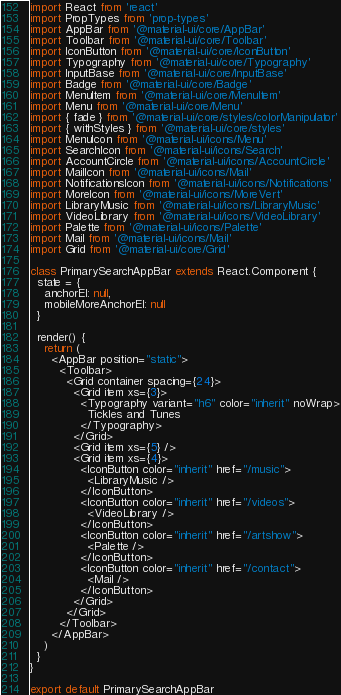Convert code to text. <code><loc_0><loc_0><loc_500><loc_500><_JavaScript_>import React from 'react'
import PropTypes from 'prop-types'
import AppBar from '@material-ui/core/AppBar'
import Toolbar from '@material-ui/core/Toolbar'
import IconButton from '@material-ui/core/IconButton'
import Typography from '@material-ui/core/Typography'
import InputBase from '@material-ui/core/InputBase'
import Badge from '@material-ui/core/Badge'
import MenuItem from '@material-ui/core/MenuItem'
import Menu from '@material-ui/core/Menu'
import { fade } from '@material-ui/core/styles/colorManipulator'
import { withStyles } from '@material-ui/core/styles'
import MenuIcon from '@material-ui/icons/Menu'
import SearchIcon from '@material-ui/icons/Search'
import AccountCircle from '@material-ui/icons/AccountCircle'
import MailIcon from '@material-ui/icons/Mail'
import NotificationsIcon from '@material-ui/icons/Notifications'
import MoreIcon from '@material-ui/icons/MoreVert'
import LibraryMusic from '@material-ui/icons/LibraryMusic'
import VideoLibrary from '@material-ui/icons/VideoLibrary'
import Palette from '@material-ui/icons/Palette'
import Mail from '@material-ui/icons/Mail'
import Grid from '@material-ui/core/Grid'

class PrimarySearchAppBar extends React.Component {
  state = {
    anchorEl: null,
    mobileMoreAnchorEl: null
  }

  render() {
    return (
      <AppBar position="static">
        <Toolbar>
          <Grid container spacing={24}>
            <Grid item xs={3}>
              <Typography variant="h6" color="inherit" noWrap>
                Tickles and Tunes
              </Typography>
            </Grid>
            <Grid item xs={5} />
            <Grid item xs={4}>
              <IconButton color="inherit" href="/music">
                <LibraryMusic />
              </IconButton>
              <IconButton color="inherit" href="/videos">
                <VideoLibrary />
              </IconButton>
              <IconButton color="inherit" href="/artshow">
                <Palette />
              </IconButton>
              <IconButton color="inherit" href="/contact">
                <Mail />
              </IconButton>
            </Grid>
          </Grid>
        </Toolbar>
      </AppBar>
    )
  }
}

export default PrimarySearchAppBar
</code> 